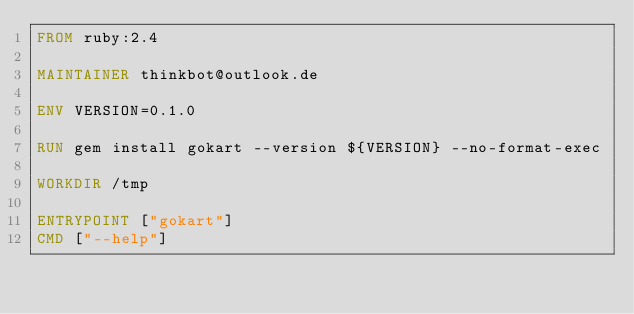<code> <loc_0><loc_0><loc_500><loc_500><_Dockerfile_>FROM ruby:2.4

MAINTAINER thinkbot@outlook.de

ENV VERSION=0.1.0

RUN gem install gokart --version ${VERSION} --no-format-exec

WORKDIR /tmp

ENTRYPOINT ["gokart"]
CMD ["--help"]
</code> 